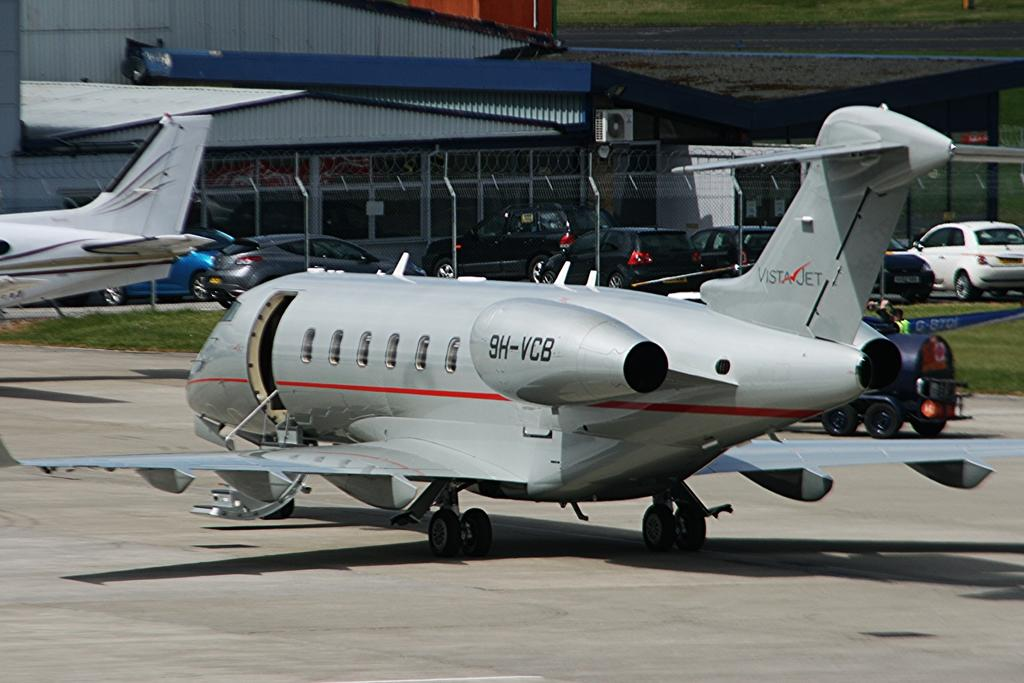<image>
Describe the image concisely. a grey and red airplane sitting on a runway with the 9H-VCB on a turbine. 